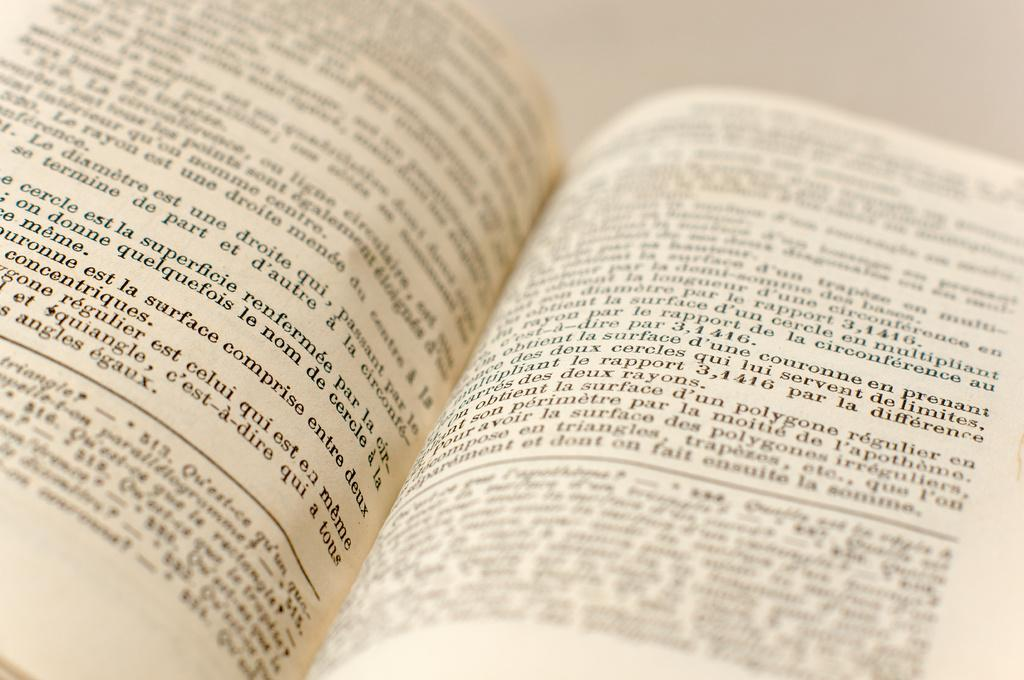<image>
Write a terse but informative summary of the picture. The number 3,1416 is visible on the right hand page. 